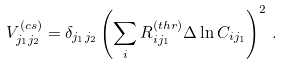<formula> <loc_0><loc_0><loc_500><loc_500>V ^ { ( c s ) } _ { j _ { 1 } j _ { 2 } } = \delta _ { j _ { 1 } j _ { 2 } } \left ( \sum _ { i } R _ { i j _ { 1 } } ^ { ( t h r ) } \Delta \ln C _ { i j _ { 1 } } \right ) ^ { 2 } \, .</formula> 